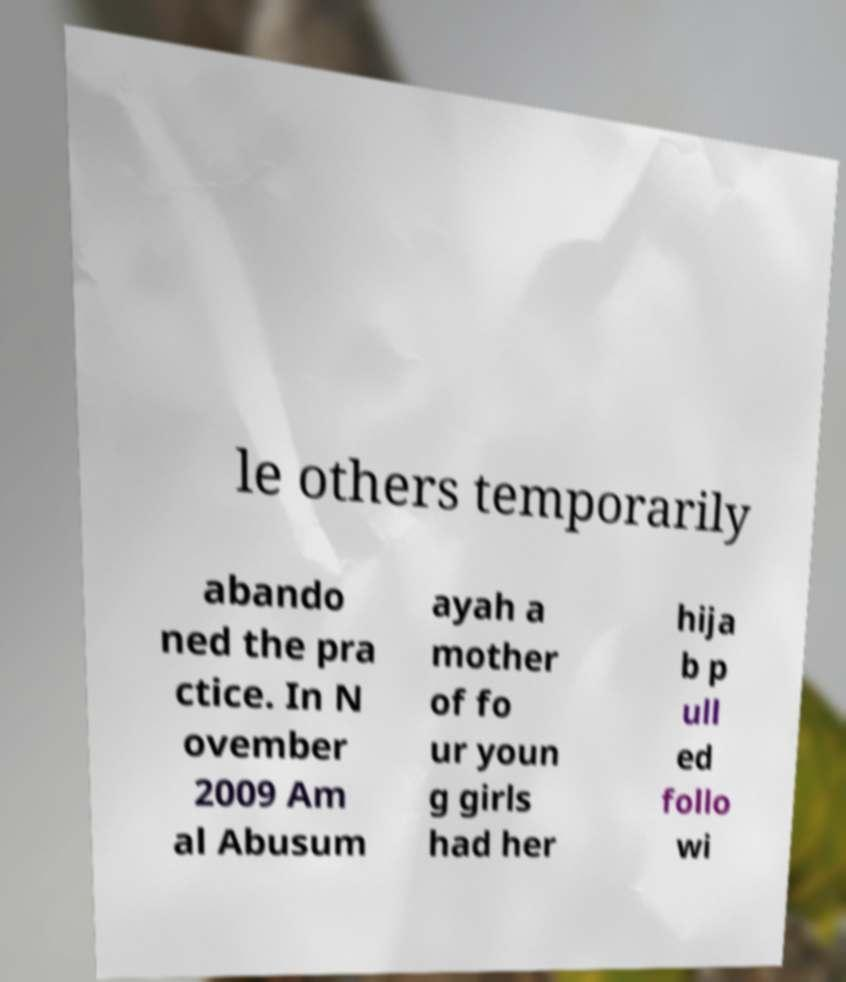Can you accurately transcribe the text from the provided image for me? le others temporarily abando ned the pra ctice. In N ovember 2009 Am al Abusum ayah a mother of fo ur youn g girls had her hija b p ull ed follo wi 